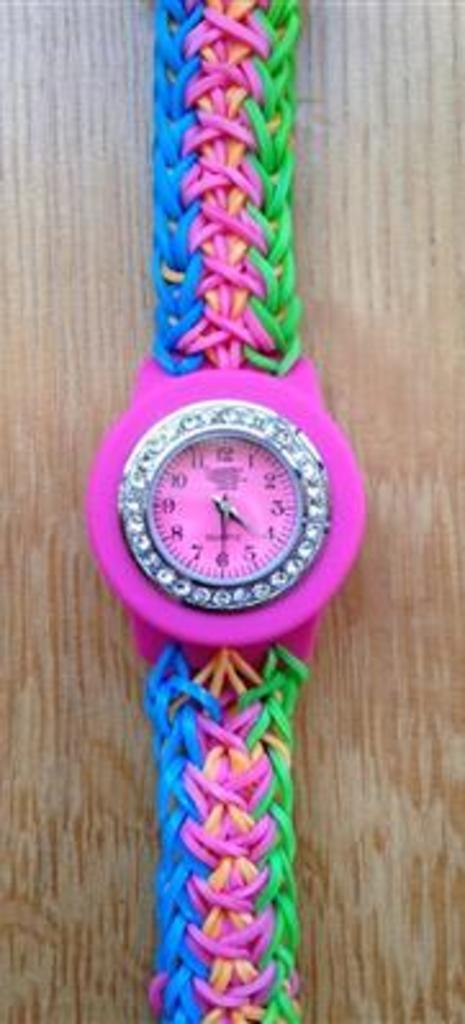<image>
Write a terse but informative summary of the picture. A rhinestone-crusted watch with the time 4:30 on it. 